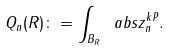Convert formula to latex. <formula><loc_0><loc_0><loc_500><loc_500>Q _ { n } ( R ) \colon = \int _ { B _ { R } } \ a b s { z ^ { k } _ { n } } ^ { p } .</formula> 